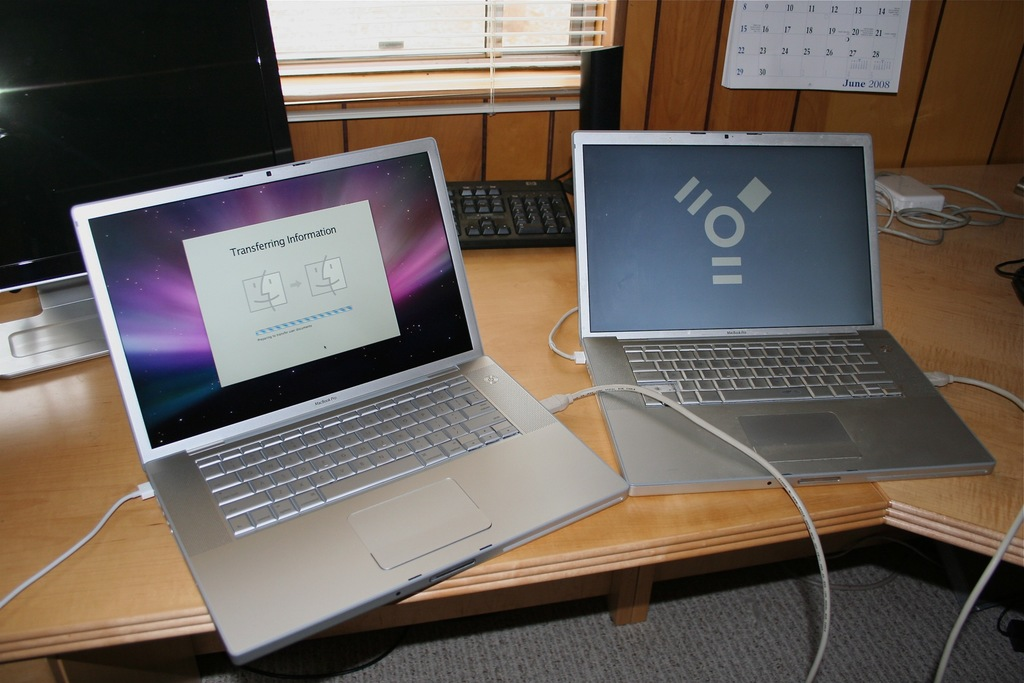Provide a one-sentence caption for the provided image. Two older model Apple MacBook laptops are connected via a cable, displaying a screen that illustrates the process of transferring information, in an office setting with visible calendar and other office items. 